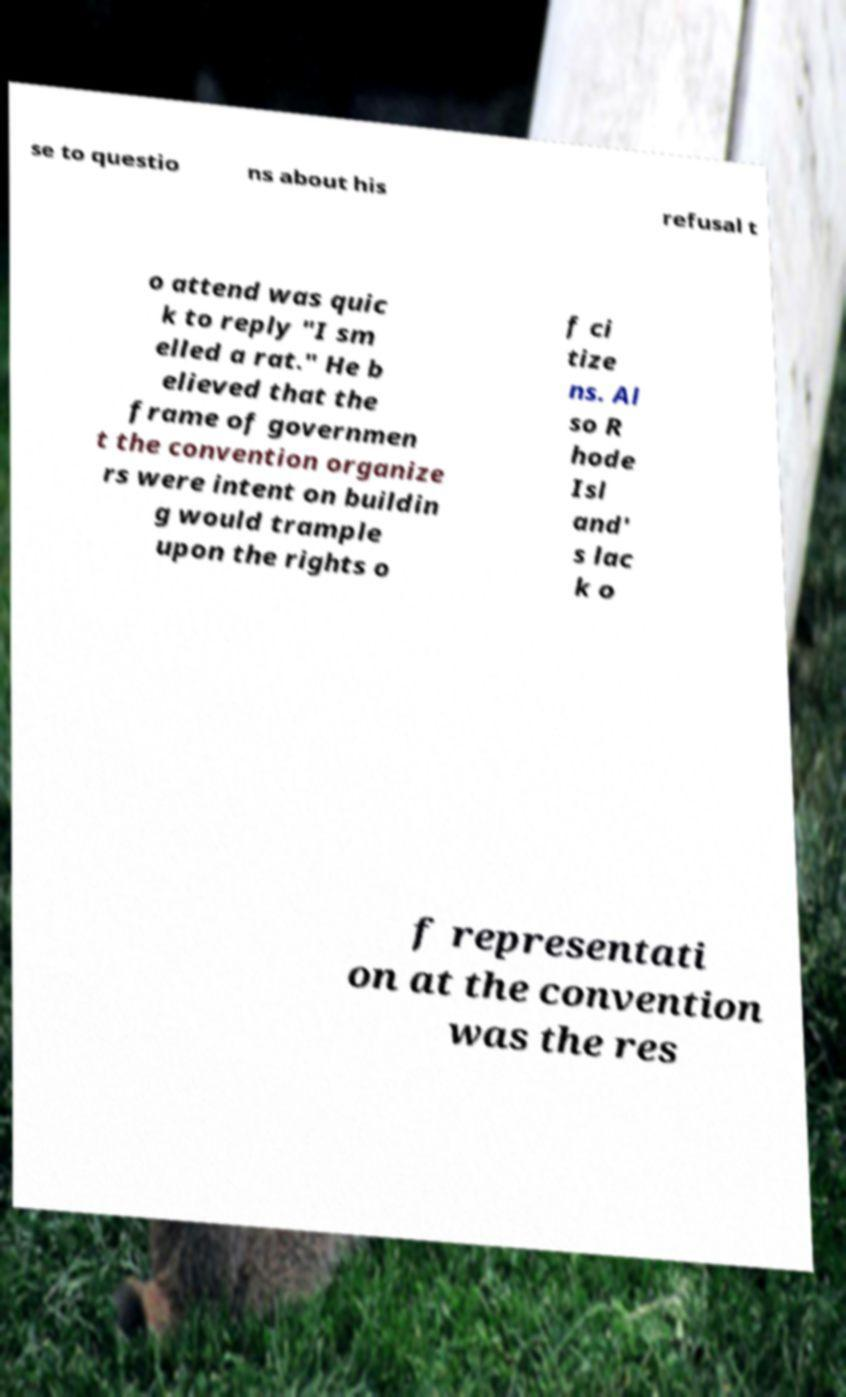Please identify and transcribe the text found in this image. se to questio ns about his refusal t o attend was quic k to reply "I sm elled a rat." He b elieved that the frame of governmen t the convention organize rs were intent on buildin g would trample upon the rights o f ci tize ns. Al so R hode Isl and' s lac k o f representati on at the convention was the res 